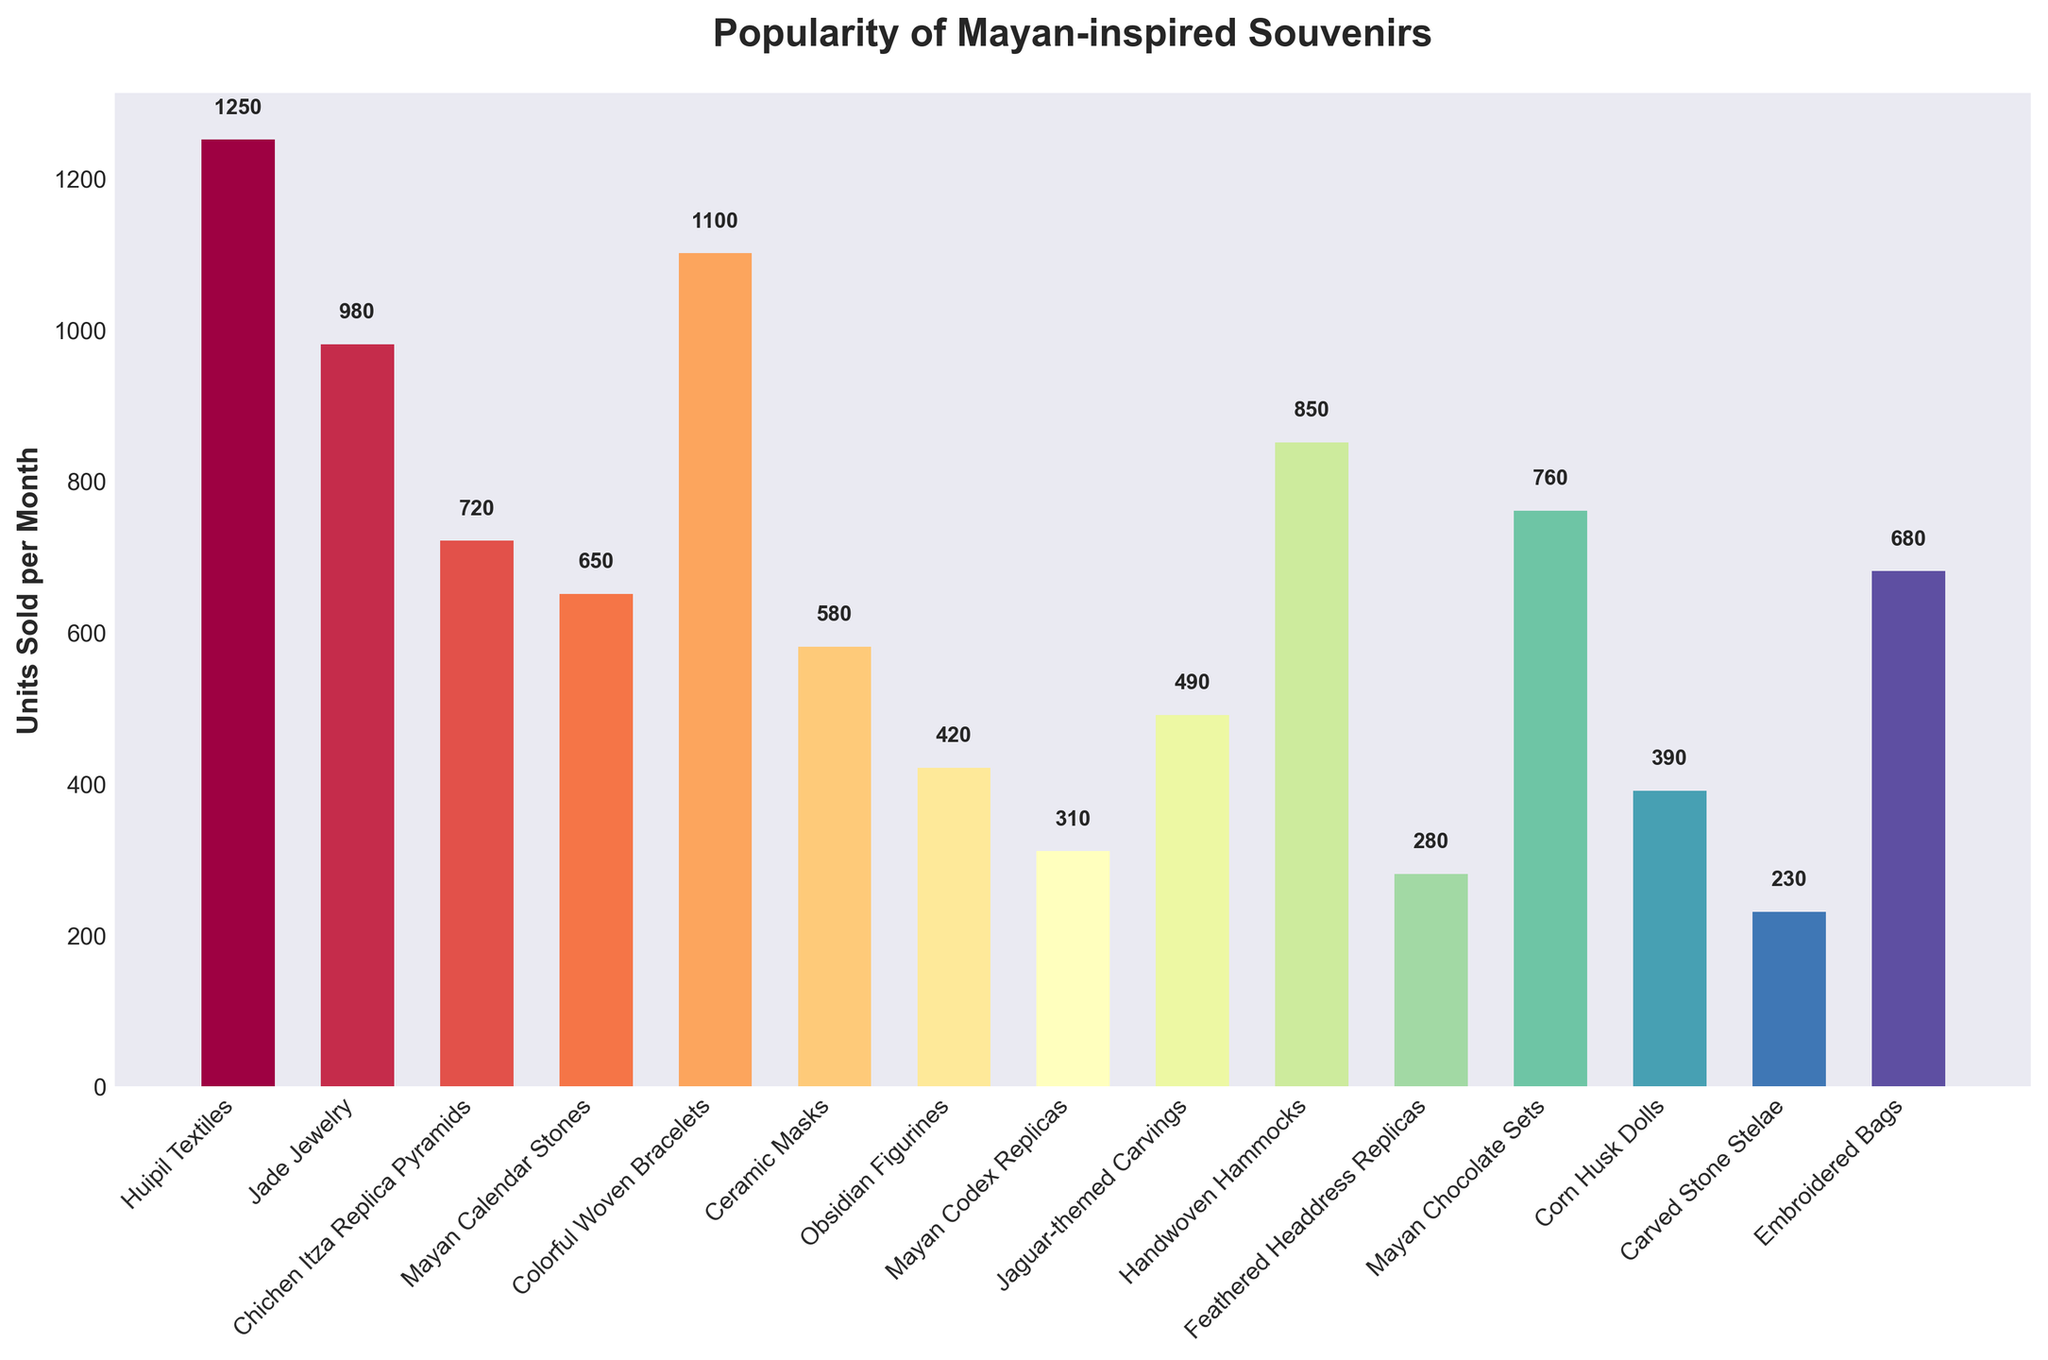Which souvenir type is the most popular? By looking at the heights of the bars, the tallest bar corresponds to "Huipil Textiles", which appears to have the highest units sold per month.
Answer: Huipil Textiles Which two souvenir types have the closest units sold per month? The bars for "Jade Jewelry" and "Embroidered Bags" appear to have similar heights, corresponding to 980 and 680 units sold per month, respectively.
Answer: Jade Jewelry and Embroidered Bags What is the total number of units sold per month for Chichen Itza Replica Pyramids and Mayan Chocolate Sets combined? The units sold for Chichen Itza Replica Pyramids is 720, and for Mayan Chocolate Sets is 760. Summing these gives 720 + 760 = 1480.
Answer: 1480 Which souvenir type has units sold that is less than Mayan Calendar Stones but more than Ceramic Masks? Mayan Calendar Stones have 650 units sold, and Ceramic Masks have 580 units sold. "Embroidered Bags" have 680 units sold, which is more than Ceramic Masks but less than Mayan Calendar Stones.
Answer: Embroidered Bags How many more units are sold per month of Colorful Woven Bracelets compared to Feathered Headdress Replicas? Colorful Woven Bracelets sell 1100 units per month, and Feathered Headdress Replicas sell 280 units per month. The difference is 1100 - 280 = 820 units.
Answer: 820 Which souvenir type has the third lowest number of units sold per month? By arranging the data in increasing order, Feathered Headdress Replicas (280), Carved Stone Stelae (230), and Mayan Codex Replicas (310) are the lowest. Thus, the third lowest is Mayan Codex Replicas.
Answer: Mayan Codex Replicas What is the average number of units sold per month for the top 5 selling souvenirs? The top 5 selling souvenirs are Huipil Textiles (1250), Colorful Woven Bracelets (1100), Mayan Chocolate Sets (760), Handwoven Hammocks (850), and Jade Jewelry (980). The average is (1250 + 1100 + 760 + 850 + 980) / 5 = 988.
Answer: 988 If you combine the units sold per month of the two least popular souvenirs, what percentage do they represent compared to the most popular? The two least popular are Carved Stone Stelae (230) and Feathered Headdress Replicas (280), combined is 230 + 280 = 510. The most popular, Huipil Textiles, sells 1250 units. The percentage is (510 / 1250) * 100 = 40.8%.
Answer: 40.8% Which souvenirs have more units sold per month than Mayan Codex Replicas but fewer than Ceramic Masks? Mayan Codex Replicas sell 310 units per month and Ceramic Masks sell 580 units per month. "Jaguar-themed Carvings" with 490 units sold fall in this range.
Answer: Jaguar-themed Carvings What is the difference in units sold per month between the least popular and the most popular souvenir? The least popular is Carved Stone Stelae with 230 units sold and the most popular is Huipil Textiles with 1250 units sold. The difference is 1250 - 230 = 1020 units.
Answer: 1020 